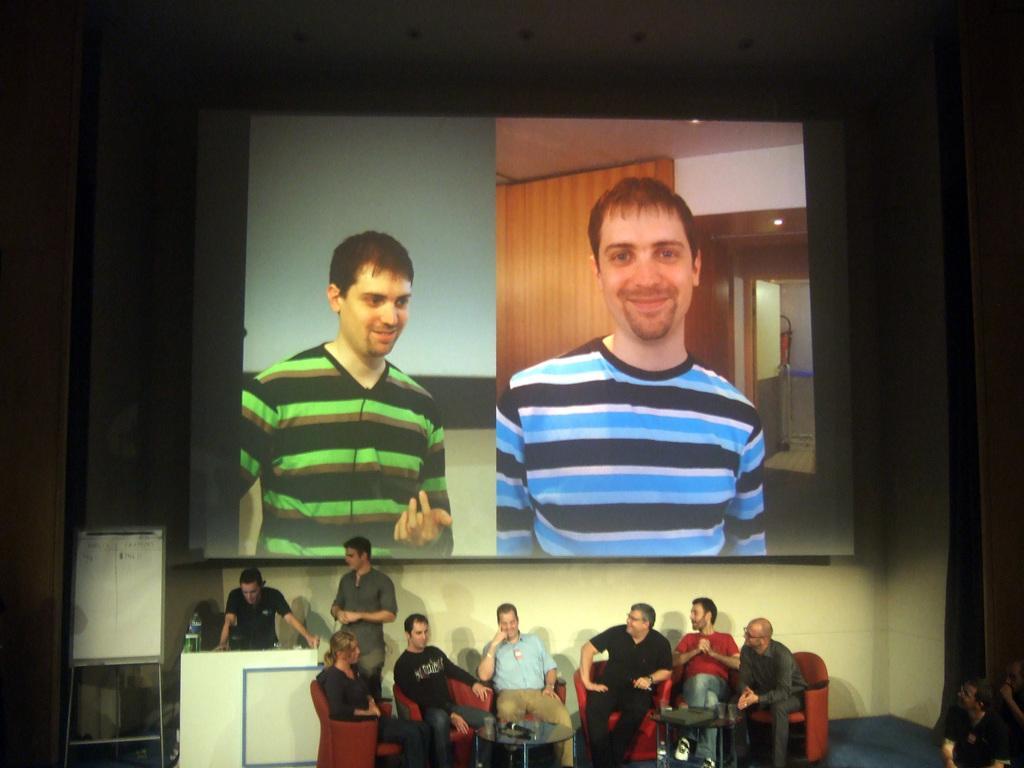Could you give a brief overview of what you see in this image? In this image, we can see persons wearing clothes. There are some persons sitting on chairs in front of tables. There is a board in the bottom left of the image. There is a screen in the middle of the image. 